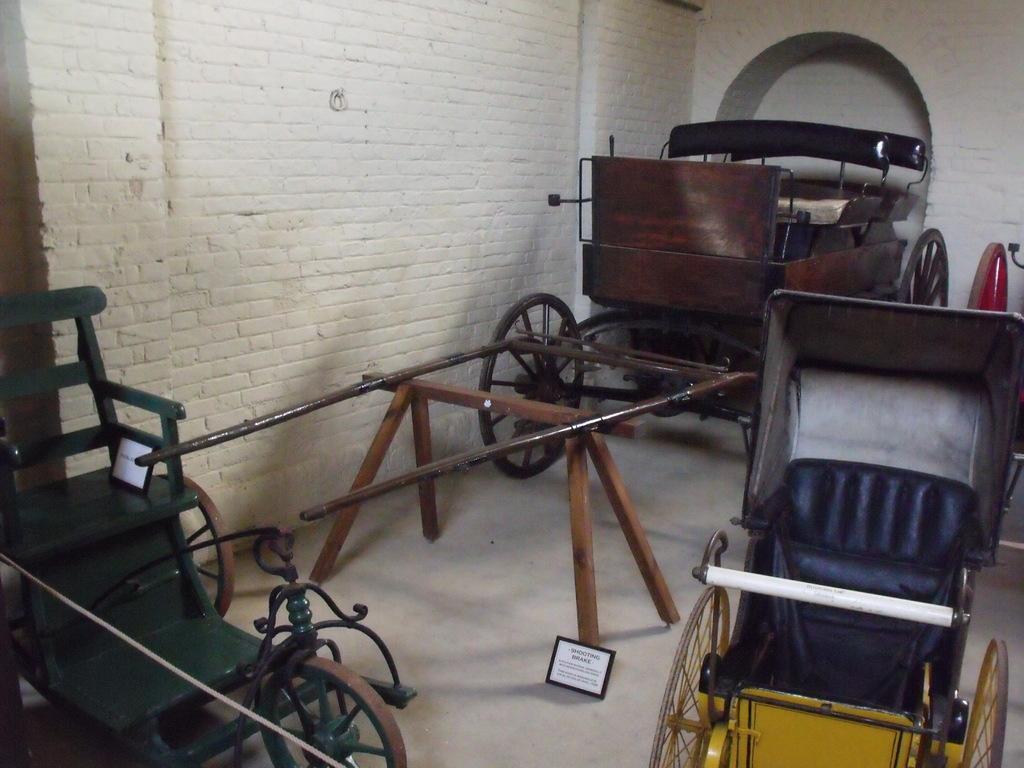Could you give a brief overview of what you see in this image? In the foreground of this image, it seems like there are three cart vehicles on the floor and also there are two boards. In the background, there is a wall and an arch. 